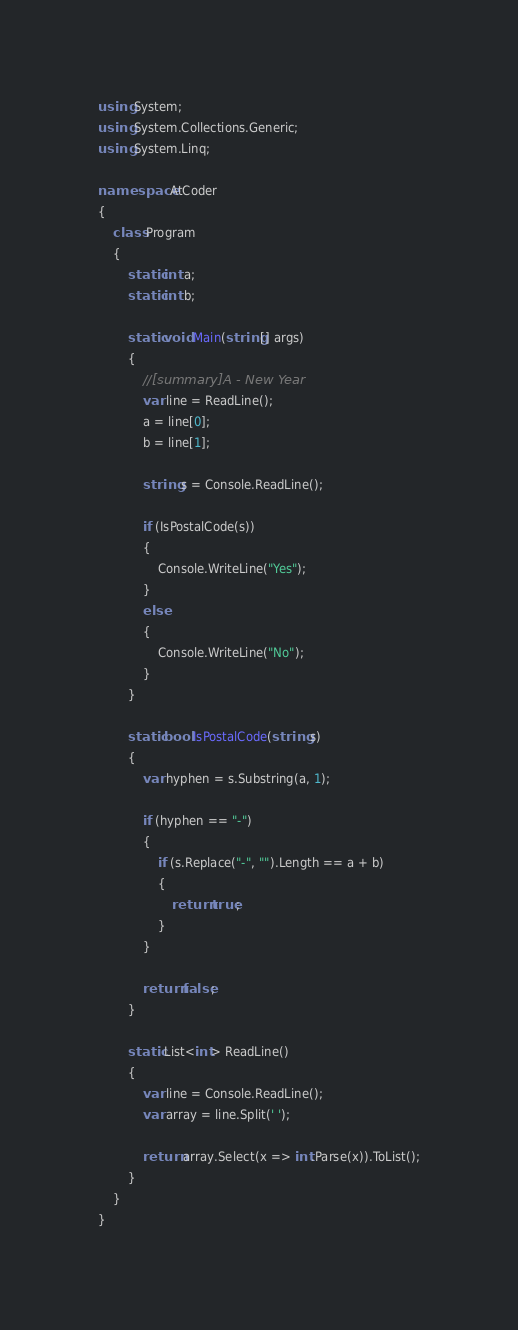<code> <loc_0><loc_0><loc_500><loc_500><_C#_>using System;
using System.Collections.Generic;
using System.Linq;

namespace AtCoder
{
    class Program
    {
        static int a;
        static int b;

        static void Main(string[] args)
        {
            //[summary]A - New Year
            var line = ReadLine();
            a = line[0];
            b = line[1];

            string s = Console.ReadLine();

            if (IsPostalCode(s))
            {
                Console.WriteLine("Yes");
            }
            else
            {
                Console.WriteLine("No");
            }
        }

        static bool IsPostalCode(string s)
        {
            var hyphen = s.Substring(a, 1);

            if (hyphen == "-")
            {
                if (s.Replace("-", "").Length == a + b)
                {
                    return true;
                }
            }

            return false;
        }

        static List<int> ReadLine()
        {
            var line = Console.ReadLine();
            var array = line.Split(' ');

            return array.Select(x => int.Parse(x)).ToList();
        }
    }
}</code> 